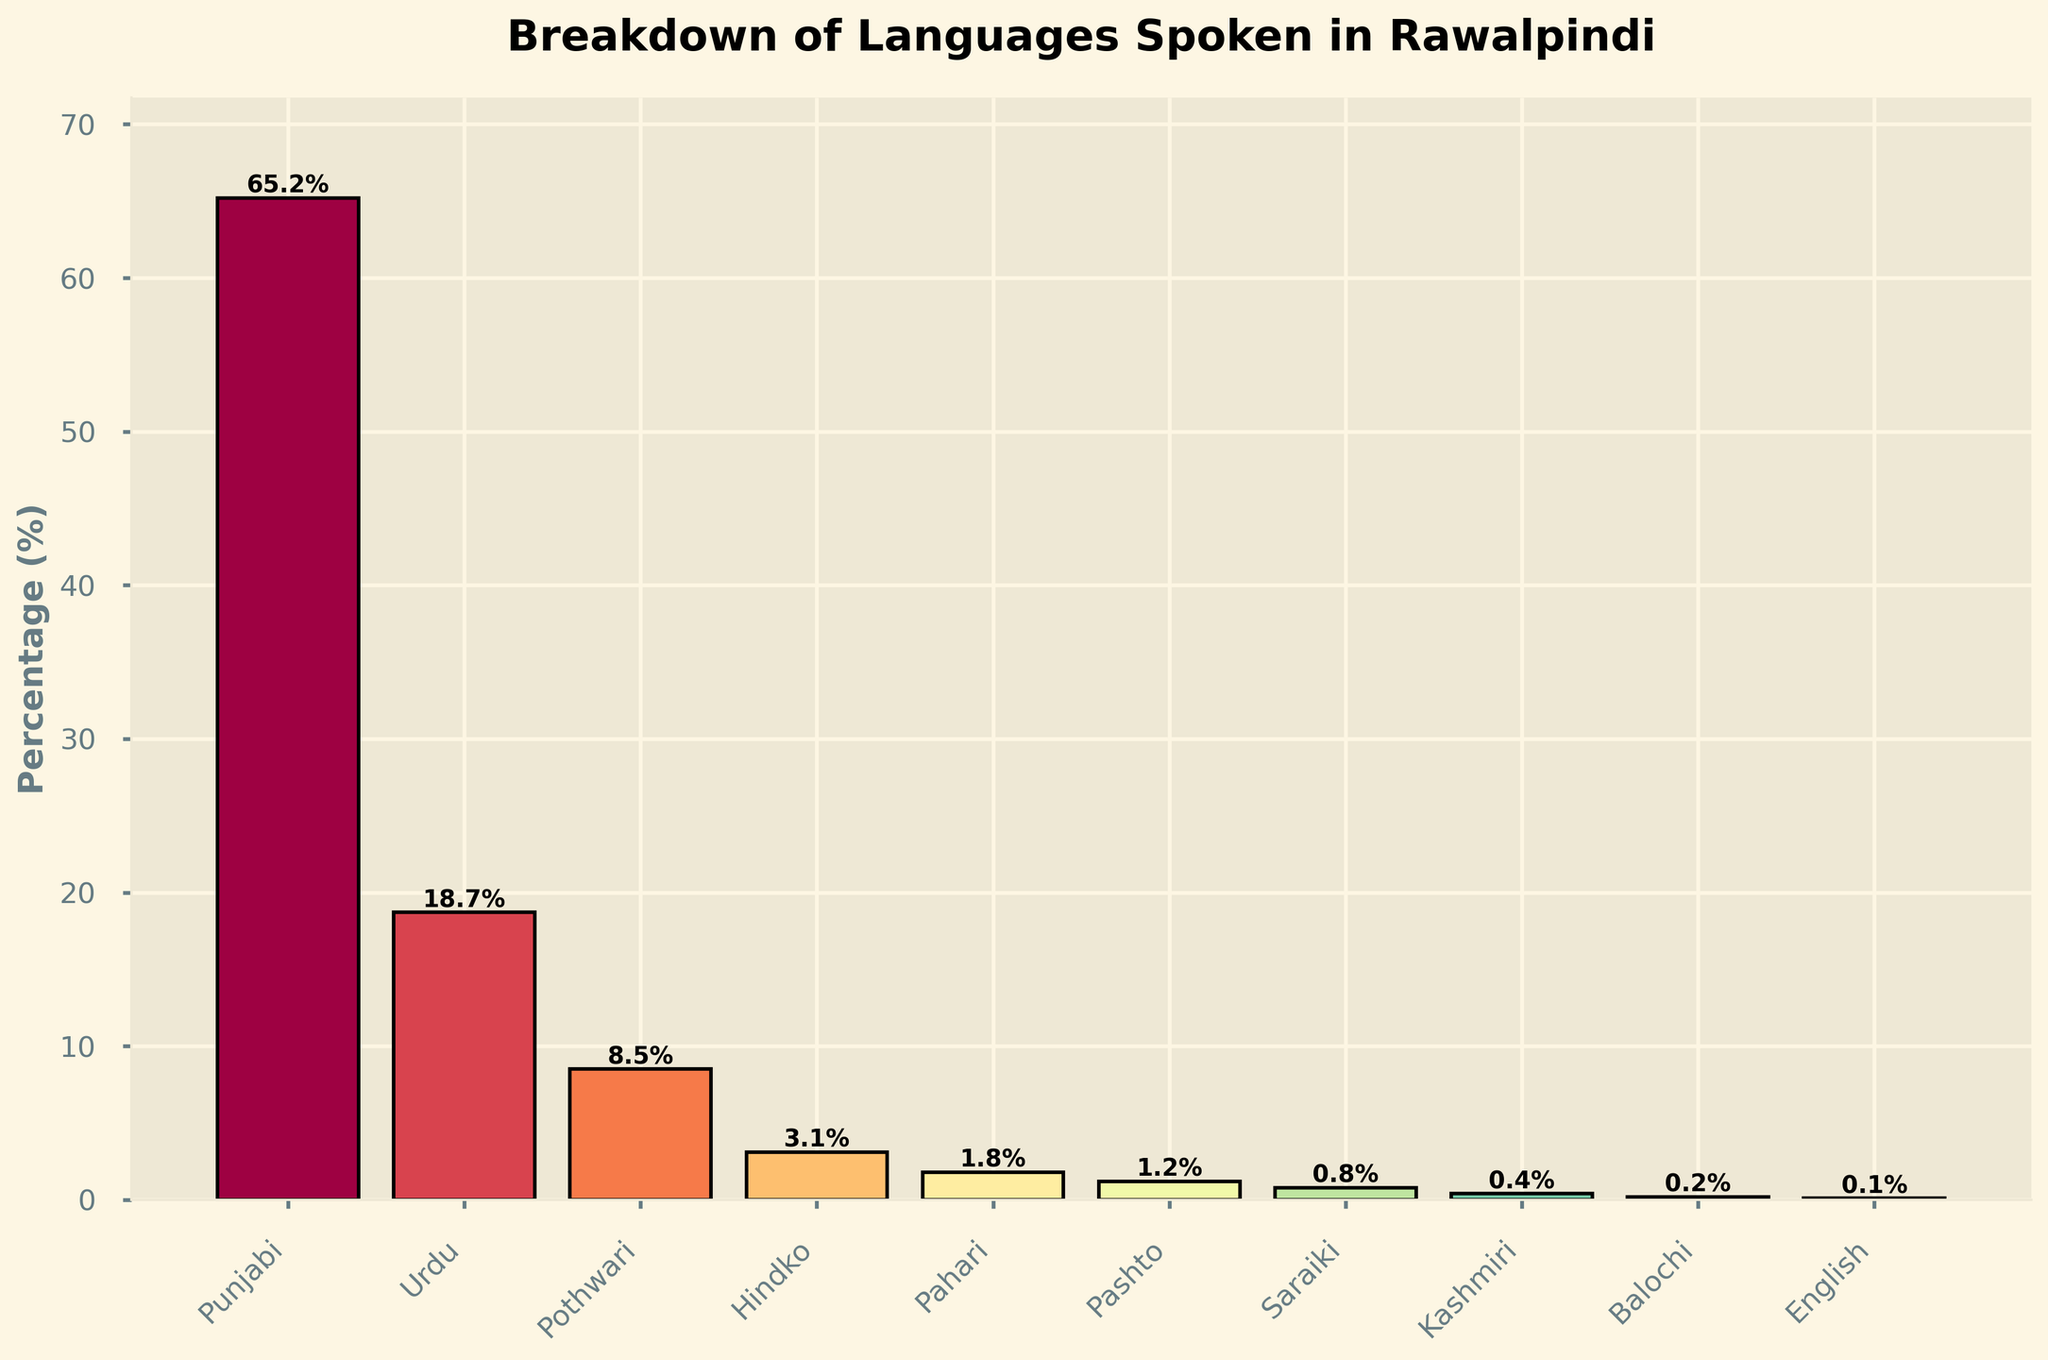What language represents the highest percentage in Rawalpindi? The bar representing Punjabi is the tallest, indicating it has the highest percentage.
Answer: Punjabi Which language has a higher percentage, Urdu or Pothwari? By comparing the height of the bars, it is evident that the bar for Urdu is taller than the bar for Pothwari.
Answer: Urdu What is the combined percentage of Urdu and Pothwari speakers? From the bars, Urdu is 18.7% and Pothwari is 8.5%. Adding these values: 18.7 + 8.5 = 27.2.
Answer: 27.2% How many languages have a percentage greater than 5%? The languages with bars taller than 5% are Punjabi, Urdu, and Pothwari. In total, there are three such languages.
Answer: 3 What's the difference in percentage between Punjabi and English speakers? Punjabi is 65.2% and English is 0.1%, the difference is: 65.2 - 0.1 = 65.1.
Answer: 65.1% Which language has the lowest percentage in Rawalpindi? The shortest bar represents English, which is at 0.1%.
Answer: English What is the average percentage of Hindko, Pahari, and Pashto speakers? Hindko is 3.1%, Pahari is 1.8%, and Pashto is 1.2%. Adding these: 3.1 + 1.8 + 1.2 = 6.1 and then dividing by 3 gives: 6.1 / 3 = 2.03.
Answer: 2.03% Are there more Pashto or Saraiki speakers according to the bar chart? The bar for Pashto is taller than the bar for Saraiki, indicating there are more Pashto speakers.
Answer: Pashto By how much does the percentage of Kashmiri speakers exceed that of Balochi speakers? Kashmiri is 0.4% and Balochi is 0.2%. The difference is: 0.4 - 0.2 = 0.2.
Answer: 0.2% Which languages together make up more than 70% of the population? The bars for Punjabi (65.2%) and Urdu (18.7%) combine to exceed 70%: 65.2 + 18.7 = 83.9%.
Answer: Punjabi and Urdu 